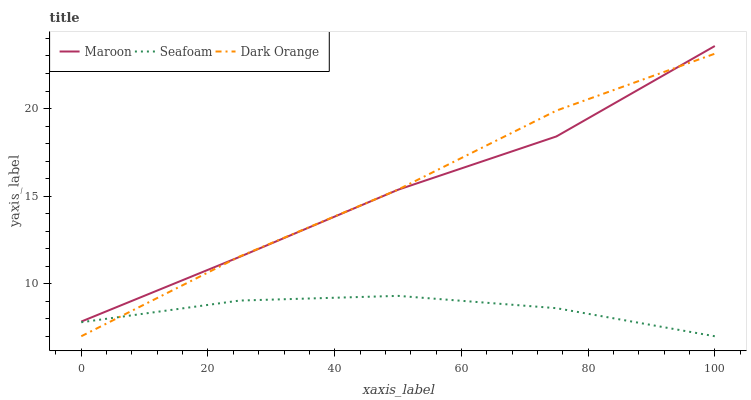Does Seafoam have the minimum area under the curve?
Answer yes or no. Yes. Does Dark Orange have the maximum area under the curve?
Answer yes or no. Yes. Does Maroon have the minimum area under the curve?
Answer yes or no. No. Does Maroon have the maximum area under the curve?
Answer yes or no. No. Is Dark Orange the smoothest?
Answer yes or no. Yes. Is Maroon the roughest?
Answer yes or no. Yes. Is Seafoam the smoothest?
Answer yes or no. No. Is Seafoam the roughest?
Answer yes or no. No. Does Dark Orange have the lowest value?
Answer yes or no. Yes. Does Maroon have the lowest value?
Answer yes or no. No. Does Maroon have the highest value?
Answer yes or no. Yes. Does Seafoam have the highest value?
Answer yes or no. No. Is Seafoam less than Maroon?
Answer yes or no. Yes. Is Maroon greater than Seafoam?
Answer yes or no. Yes. Does Seafoam intersect Dark Orange?
Answer yes or no. Yes. Is Seafoam less than Dark Orange?
Answer yes or no. No. Is Seafoam greater than Dark Orange?
Answer yes or no. No. Does Seafoam intersect Maroon?
Answer yes or no. No. 